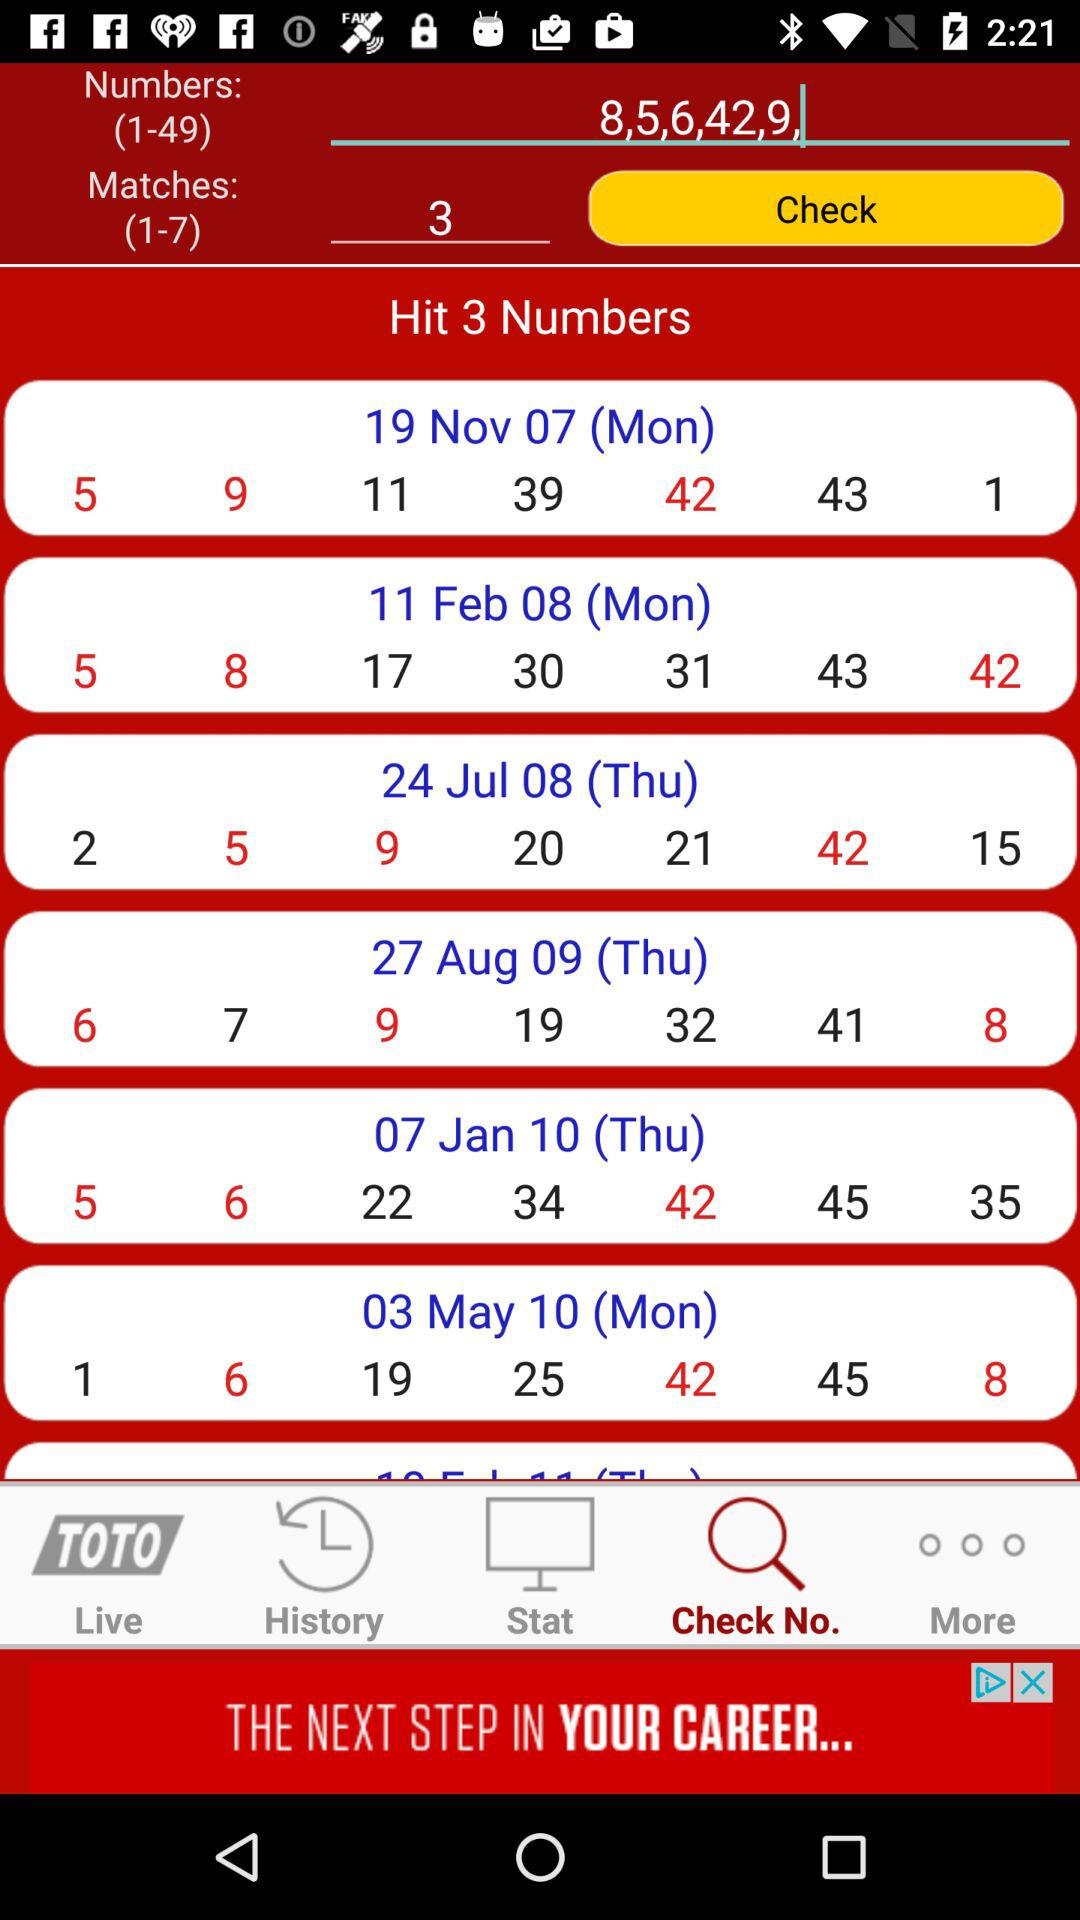What are the entered numbers in the numbers section? The entered numbers are "8,5,6,42,9,". 